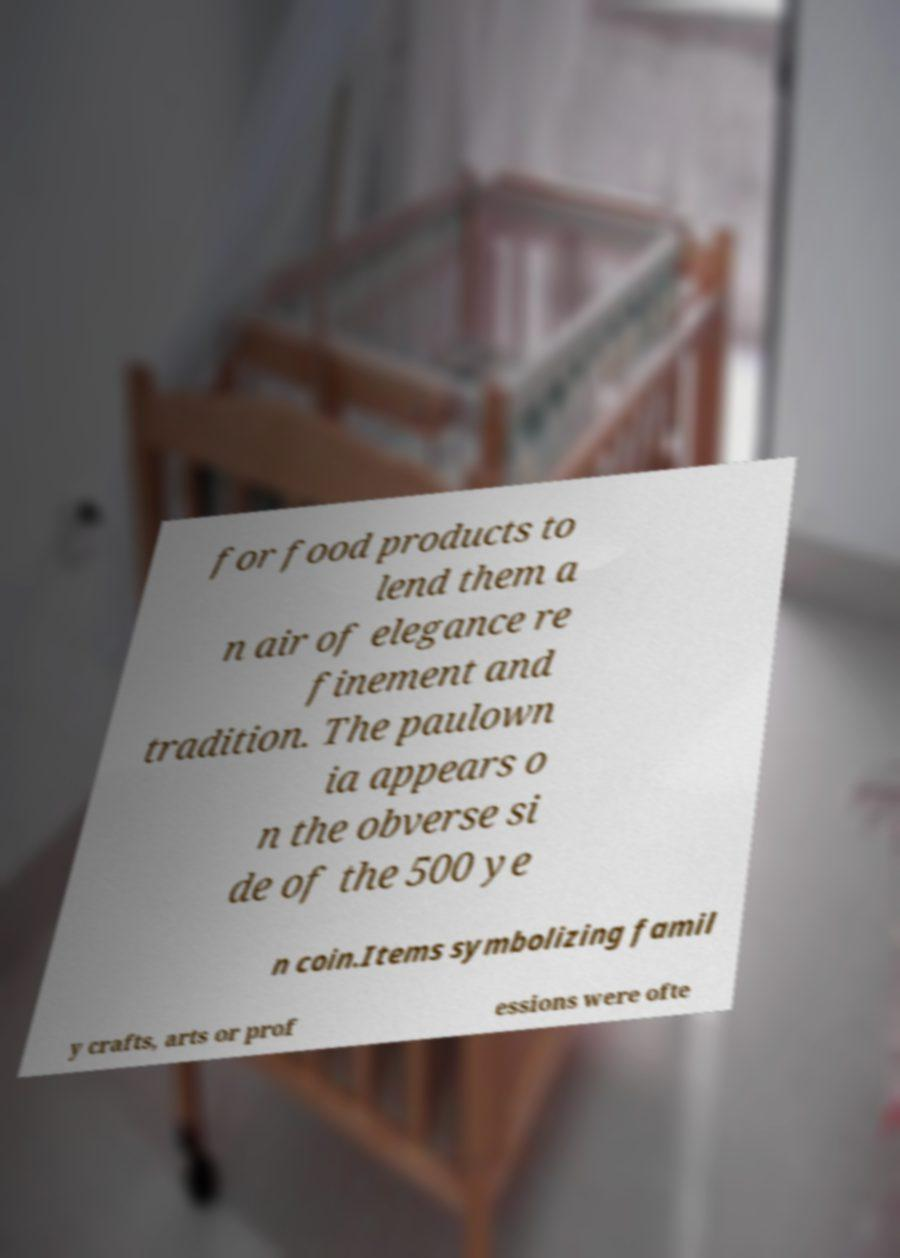Could you assist in decoding the text presented in this image and type it out clearly? for food products to lend them a n air of elegance re finement and tradition. The paulown ia appears o n the obverse si de of the 500 ye n coin.Items symbolizing famil y crafts, arts or prof essions were ofte 